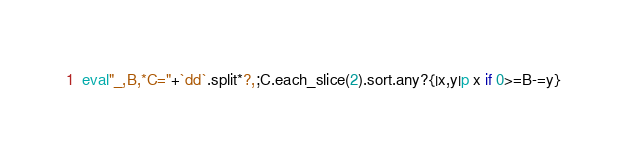<code> <loc_0><loc_0><loc_500><loc_500><_Ruby_>eval"_,B,*C="+`dd`.split*?,;C.each_slice(2).sort.any?{|x,y|p x if 0>=B-=y}</code> 